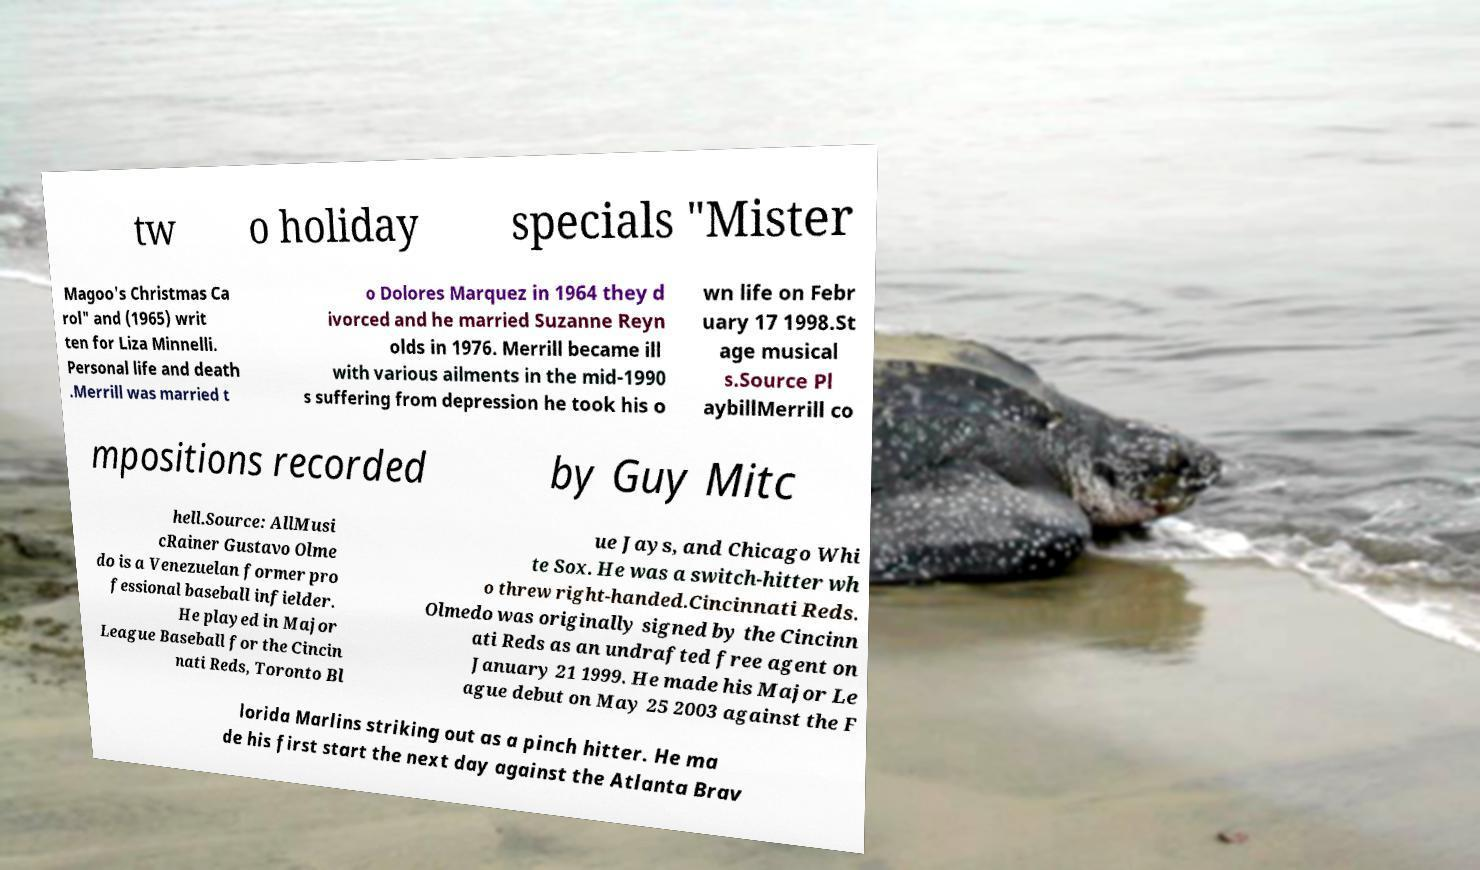For documentation purposes, I need the text within this image transcribed. Could you provide that? tw o holiday specials "Mister Magoo's Christmas Ca rol" and (1965) writ ten for Liza Minnelli. Personal life and death .Merrill was married t o Dolores Marquez in 1964 they d ivorced and he married Suzanne Reyn olds in 1976. Merrill became ill with various ailments in the mid-1990 s suffering from depression he took his o wn life on Febr uary 17 1998.St age musical s.Source Pl aybillMerrill co mpositions recorded by Guy Mitc hell.Source: AllMusi cRainer Gustavo Olme do is a Venezuelan former pro fessional baseball infielder. He played in Major League Baseball for the Cincin nati Reds, Toronto Bl ue Jays, and Chicago Whi te Sox. He was a switch-hitter wh o threw right-handed.Cincinnati Reds. Olmedo was originally signed by the Cincinn ati Reds as an undrafted free agent on January 21 1999. He made his Major Le ague debut on May 25 2003 against the F lorida Marlins striking out as a pinch hitter. He ma de his first start the next day against the Atlanta Brav 